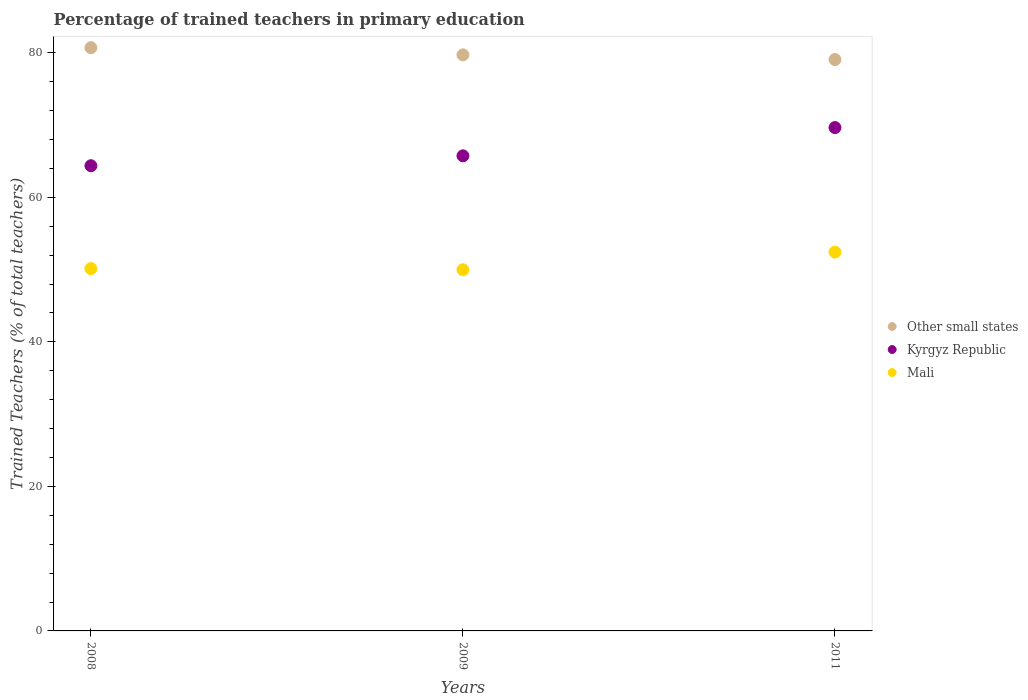Is the number of dotlines equal to the number of legend labels?
Keep it short and to the point. Yes. What is the percentage of trained teachers in Kyrgyz Republic in 2009?
Provide a succinct answer. 65.75. Across all years, what is the maximum percentage of trained teachers in Kyrgyz Republic?
Provide a succinct answer. 69.66. Across all years, what is the minimum percentage of trained teachers in Mali?
Your answer should be compact. 49.98. In which year was the percentage of trained teachers in Kyrgyz Republic minimum?
Your answer should be very brief. 2008. What is the total percentage of trained teachers in Mali in the graph?
Give a very brief answer. 152.55. What is the difference between the percentage of trained teachers in Mali in 2008 and that in 2011?
Ensure brevity in your answer.  -2.28. What is the difference between the percentage of trained teachers in Mali in 2011 and the percentage of trained teachers in Other small states in 2009?
Ensure brevity in your answer.  -27.3. What is the average percentage of trained teachers in Kyrgyz Republic per year?
Ensure brevity in your answer.  66.6. In the year 2011, what is the difference between the percentage of trained teachers in Other small states and percentage of trained teachers in Kyrgyz Republic?
Offer a terse response. 9.42. In how many years, is the percentage of trained teachers in Kyrgyz Republic greater than 36 %?
Your answer should be very brief. 3. What is the ratio of the percentage of trained teachers in Mali in 2008 to that in 2011?
Your response must be concise. 0.96. Is the difference between the percentage of trained teachers in Other small states in 2008 and 2011 greater than the difference between the percentage of trained teachers in Kyrgyz Republic in 2008 and 2011?
Your answer should be very brief. Yes. What is the difference between the highest and the second highest percentage of trained teachers in Other small states?
Provide a short and direct response. 0.99. What is the difference between the highest and the lowest percentage of trained teachers in Mali?
Ensure brevity in your answer.  2.44. Does the percentage of trained teachers in Mali monotonically increase over the years?
Your answer should be compact. No. Is the percentage of trained teachers in Other small states strictly less than the percentage of trained teachers in Kyrgyz Republic over the years?
Provide a short and direct response. No. How many years are there in the graph?
Offer a very short reply. 3. What is the difference between two consecutive major ticks on the Y-axis?
Your answer should be very brief. 20. Does the graph contain any zero values?
Provide a succinct answer. No. Does the graph contain grids?
Your response must be concise. No. Where does the legend appear in the graph?
Provide a succinct answer. Center right. How many legend labels are there?
Give a very brief answer. 3. How are the legend labels stacked?
Your response must be concise. Vertical. What is the title of the graph?
Your answer should be compact. Percentage of trained teachers in primary education. Does "Nepal" appear as one of the legend labels in the graph?
Your answer should be compact. No. What is the label or title of the X-axis?
Offer a terse response. Years. What is the label or title of the Y-axis?
Provide a short and direct response. Trained Teachers (% of total teachers). What is the Trained Teachers (% of total teachers) of Other small states in 2008?
Provide a short and direct response. 80.71. What is the Trained Teachers (% of total teachers) of Kyrgyz Republic in 2008?
Offer a very short reply. 64.38. What is the Trained Teachers (% of total teachers) in Mali in 2008?
Your answer should be very brief. 50.14. What is the Trained Teachers (% of total teachers) in Other small states in 2009?
Give a very brief answer. 79.72. What is the Trained Teachers (% of total teachers) in Kyrgyz Republic in 2009?
Give a very brief answer. 65.75. What is the Trained Teachers (% of total teachers) in Mali in 2009?
Provide a short and direct response. 49.98. What is the Trained Teachers (% of total teachers) of Other small states in 2011?
Give a very brief answer. 79.07. What is the Trained Teachers (% of total teachers) of Kyrgyz Republic in 2011?
Ensure brevity in your answer.  69.66. What is the Trained Teachers (% of total teachers) of Mali in 2011?
Your answer should be compact. 52.42. Across all years, what is the maximum Trained Teachers (% of total teachers) of Other small states?
Make the answer very short. 80.71. Across all years, what is the maximum Trained Teachers (% of total teachers) of Kyrgyz Republic?
Keep it short and to the point. 69.66. Across all years, what is the maximum Trained Teachers (% of total teachers) in Mali?
Your answer should be compact. 52.42. Across all years, what is the minimum Trained Teachers (% of total teachers) of Other small states?
Your answer should be very brief. 79.07. Across all years, what is the minimum Trained Teachers (% of total teachers) of Kyrgyz Republic?
Provide a succinct answer. 64.38. Across all years, what is the minimum Trained Teachers (% of total teachers) in Mali?
Offer a terse response. 49.98. What is the total Trained Teachers (% of total teachers) in Other small states in the graph?
Provide a short and direct response. 239.51. What is the total Trained Teachers (% of total teachers) in Kyrgyz Republic in the graph?
Keep it short and to the point. 199.79. What is the total Trained Teachers (% of total teachers) of Mali in the graph?
Your answer should be very brief. 152.55. What is the difference between the Trained Teachers (% of total teachers) of Other small states in 2008 and that in 2009?
Offer a very short reply. 0.99. What is the difference between the Trained Teachers (% of total teachers) of Kyrgyz Republic in 2008 and that in 2009?
Your answer should be compact. -1.37. What is the difference between the Trained Teachers (% of total teachers) in Mali in 2008 and that in 2009?
Offer a terse response. 0.16. What is the difference between the Trained Teachers (% of total teachers) of Other small states in 2008 and that in 2011?
Make the answer very short. 1.64. What is the difference between the Trained Teachers (% of total teachers) of Kyrgyz Republic in 2008 and that in 2011?
Offer a very short reply. -5.28. What is the difference between the Trained Teachers (% of total teachers) in Mali in 2008 and that in 2011?
Provide a short and direct response. -2.28. What is the difference between the Trained Teachers (% of total teachers) of Other small states in 2009 and that in 2011?
Offer a terse response. 0.65. What is the difference between the Trained Teachers (% of total teachers) in Kyrgyz Republic in 2009 and that in 2011?
Offer a terse response. -3.91. What is the difference between the Trained Teachers (% of total teachers) in Mali in 2009 and that in 2011?
Keep it short and to the point. -2.44. What is the difference between the Trained Teachers (% of total teachers) in Other small states in 2008 and the Trained Teachers (% of total teachers) in Kyrgyz Republic in 2009?
Your answer should be very brief. 14.97. What is the difference between the Trained Teachers (% of total teachers) in Other small states in 2008 and the Trained Teachers (% of total teachers) in Mali in 2009?
Provide a succinct answer. 30.73. What is the difference between the Trained Teachers (% of total teachers) in Kyrgyz Republic in 2008 and the Trained Teachers (% of total teachers) in Mali in 2009?
Provide a short and direct response. 14.4. What is the difference between the Trained Teachers (% of total teachers) in Other small states in 2008 and the Trained Teachers (% of total teachers) in Kyrgyz Republic in 2011?
Keep it short and to the point. 11.06. What is the difference between the Trained Teachers (% of total teachers) of Other small states in 2008 and the Trained Teachers (% of total teachers) of Mali in 2011?
Provide a succinct answer. 28.29. What is the difference between the Trained Teachers (% of total teachers) of Kyrgyz Republic in 2008 and the Trained Teachers (% of total teachers) of Mali in 2011?
Ensure brevity in your answer.  11.96. What is the difference between the Trained Teachers (% of total teachers) in Other small states in 2009 and the Trained Teachers (% of total teachers) in Kyrgyz Republic in 2011?
Give a very brief answer. 10.06. What is the difference between the Trained Teachers (% of total teachers) in Other small states in 2009 and the Trained Teachers (% of total teachers) in Mali in 2011?
Offer a very short reply. 27.3. What is the difference between the Trained Teachers (% of total teachers) in Kyrgyz Republic in 2009 and the Trained Teachers (% of total teachers) in Mali in 2011?
Your answer should be very brief. 13.32. What is the average Trained Teachers (% of total teachers) of Other small states per year?
Give a very brief answer. 79.84. What is the average Trained Teachers (% of total teachers) of Kyrgyz Republic per year?
Keep it short and to the point. 66.59. What is the average Trained Teachers (% of total teachers) of Mali per year?
Ensure brevity in your answer.  50.85. In the year 2008, what is the difference between the Trained Teachers (% of total teachers) in Other small states and Trained Teachers (% of total teachers) in Kyrgyz Republic?
Keep it short and to the point. 16.34. In the year 2008, what is the difference between the Trained Teachers (% of total teachers) in Other small states and Trained Teachers (% of total teachers) in Mali?
Provide a short and direct response. 30.57. In the year 2008, what is the difference between the Trained Teachers (% of total teachers) in Kyrgyz Republic and Trained Teachers (% of total teachers) in Mali?
Keep it short and to the point. 14.24. In the year 2009, what is the difference between the Trained Teachers (% of total teachers) of Other small states and Trained Teachers (% of total teachers) of Kyrgyz Republic?
Ensure brevity in your answer.  13.97. In the year 2009, what is the difference between the Trained Teachers (% of total teachers) in Other small states and Trained Teachers (% of total teachers) in Mali?
Offer a terse response. 29.74. In the year 2009, what is the difference between the Trained Teachers (% of total teachers) in Kyrgyz Republic and Trained Teachers (% of total teachers) in Mali?
Your response must be concise. 15.77. In the year 2011, what is the difference between the Trained Teachers (% of total teachers) in Other small states and Trained Teachers (% of total teachers) in Kyrgyz Republic?
Provide a short and direct response. 9.42. In the year 2011, what is the difference between the Trained Teachers (% of total teachers) of Other small states and Trained Teachers (% of total teachers) of Mali?
Keep it short and to the point. 26.65. In the year 2011, what is the difference between the Trained Teachers (% of total teachers) in Kyrgyz Republic and Trained Teachers (% of total teachers) in Mali?
Make the answer very short. 17.23. What is the ratio of the Trained Teachers (% of total teachers) of Other small states in 2008 to that in 2009?
Provide a short and direct response. 1.01. What is the ratio of the Trained Teachers (% of total teachers) in Kyrgyz Republic in 2008 to that in 2009?
Your response must be concise. 0.98. What is the ratio of the Trained Teachers (% of total teachers) in Other small states in 2008 to that in 2011?
Give a very brief answer. 1.02. What is the ratio of the Trained Teachers (% of total teachers) of Kyrgyz Republic in 2008 to that in 2011?
Provide a short and direct response. 0.92. What is the ratio of the Trained Teachers (% of total teachers) of Mali in 2008 to that in 2011?
Provide a succinct answer. 0.96. What is the ratio of the Trained Teachers (% of total teachers) in Other small states in 2009 to that in 2011?
Provide a succinct answer. 1.01. What is the ratio of the Trained Teachers (% of total teachers) in Kyrgyz Republic in 2009 to that in 2011?
Give a very brief answer. 0.94. What is the ratio of the Trained Teachers (% of total teachers) in Mali in 2009 to that in 2011?
Your answer should be very brief. 0.95. What is the difference between the highest and the second highest Trained Teachers (% of total teachers) in Other small states?
Provide a short and direct response. 0.99. What is the difference between the highest and the second highest Trained Teachers (% of total teachers) in Kyrgyz Republic?
Offer a terse response. 3.91. What is the difference between the highest and the second highest Trained Teachers (% of total teachers) of Mali?
Keep it short and to the point. 2.28. What is the difference between the highest and the lowest Trained Teachers (% of total teachers) of Other small states?
Your response must be concise. 1.64. What is the difference between the highest and the lowest Trained Teachers (% of total teachers) of Kyrgyz Republic?
Your response must be concise. 5.28. What is the difference between the highest and the lowest Trained Teachers (% of total teachers) in Mali?
Make the answer very short. 2.44. 